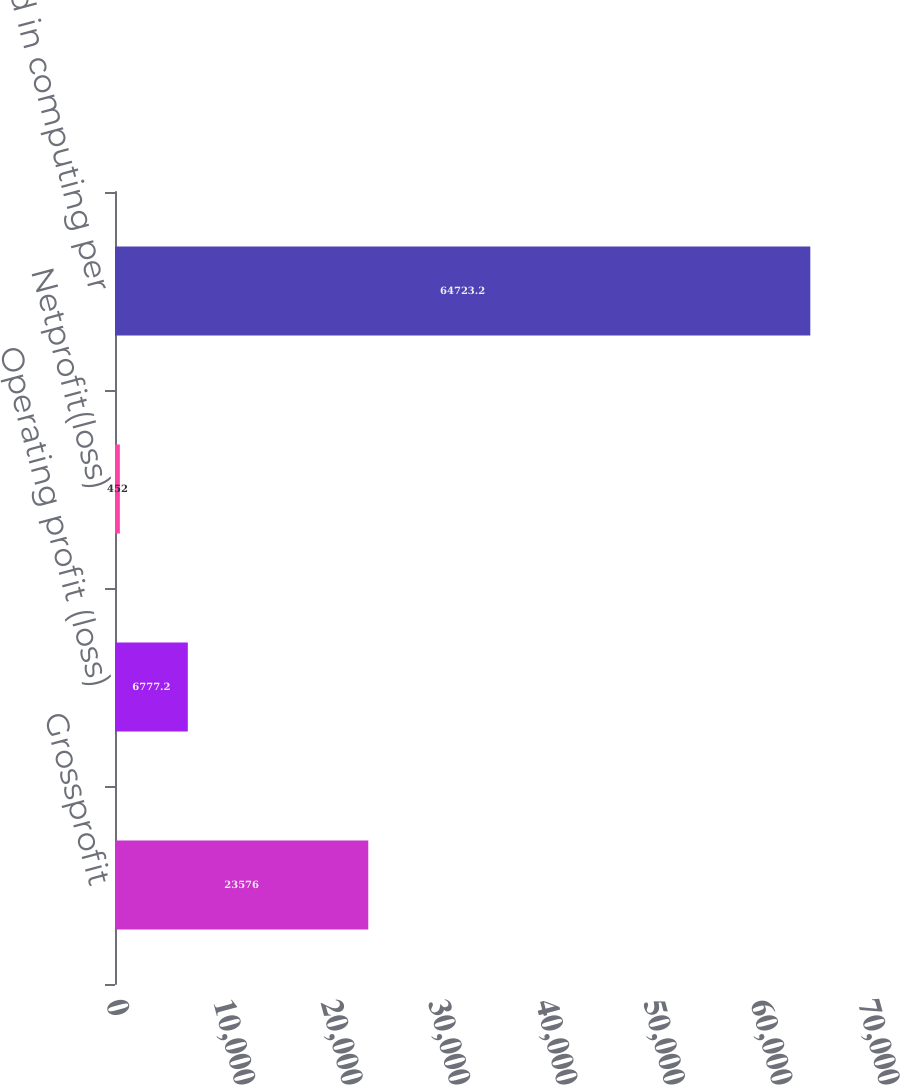Convert chart. <chart><loc_0><loc_0><loc_500><loc_500><bar_chart><fcel>Grossprofit<fcel>Operating profit (loss)<fcel>Netprofit(loss)<fcel>Shares used in computing per<nl><fcel>23576<fcel>6777.2<fcel>452<fcel>64723.2<nl></chart> 